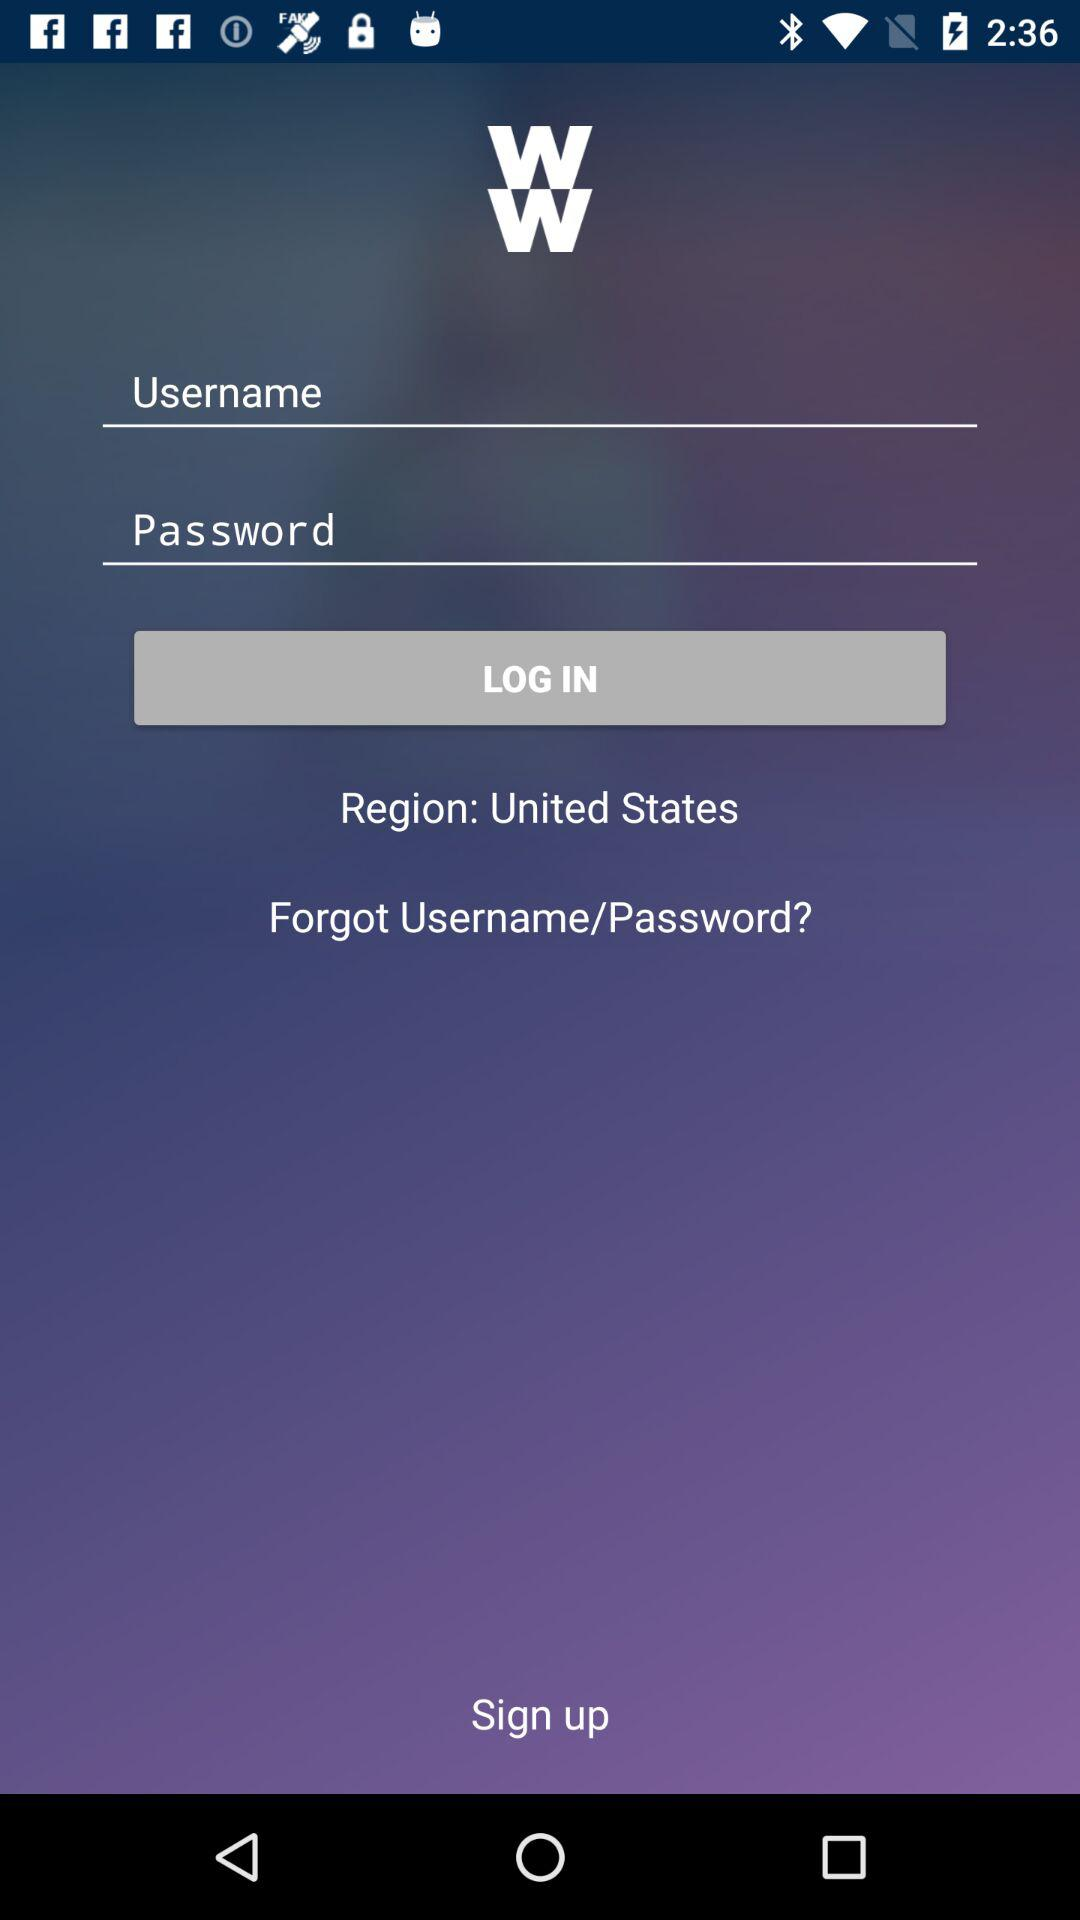What is the region? The region is the United States. 